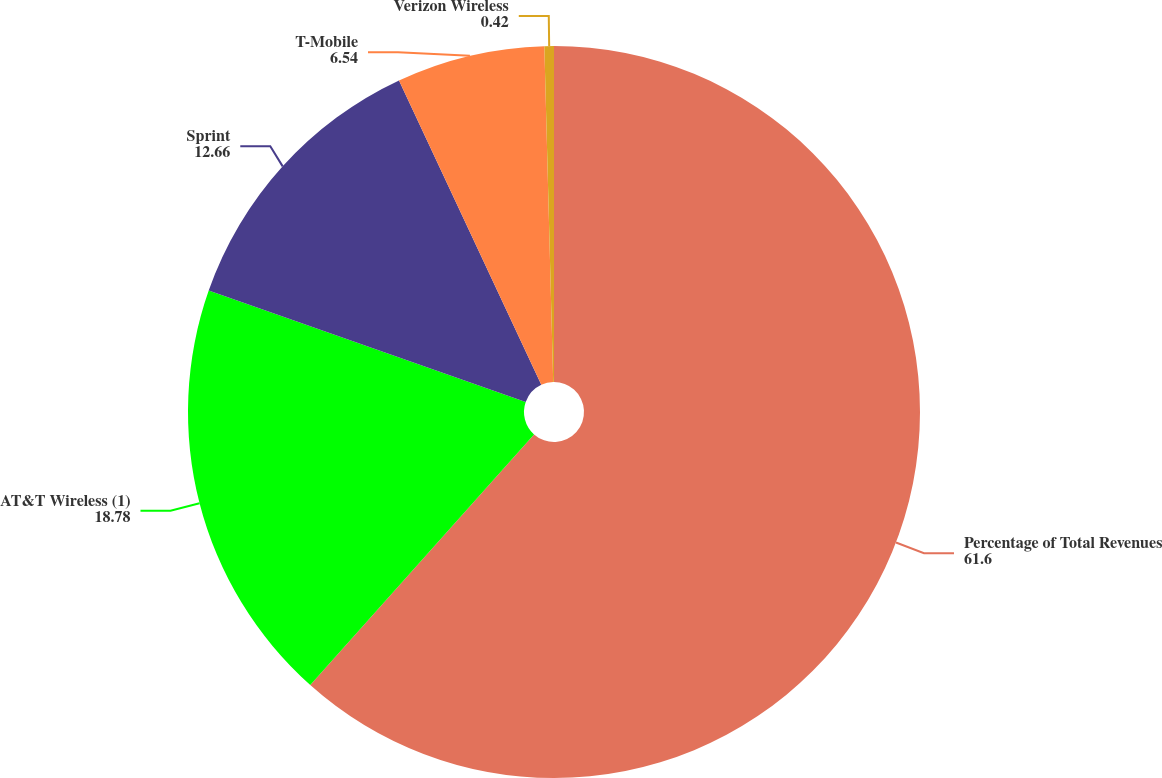Convert chart. <chart><loc_0><loc_0><loc_500><loc_500><pie_chart><fcel>Percentage of Total Revenues<fcel>AT&T Wireless (1)<fcel>Sprint<fcel>T-Mobile<fcel>Verizon Wireless<nl><fcel>61.6%<fcel>18.78%<fcel>12.66%<fcel>6.54%<fcel>0.42%<nl></chart> 